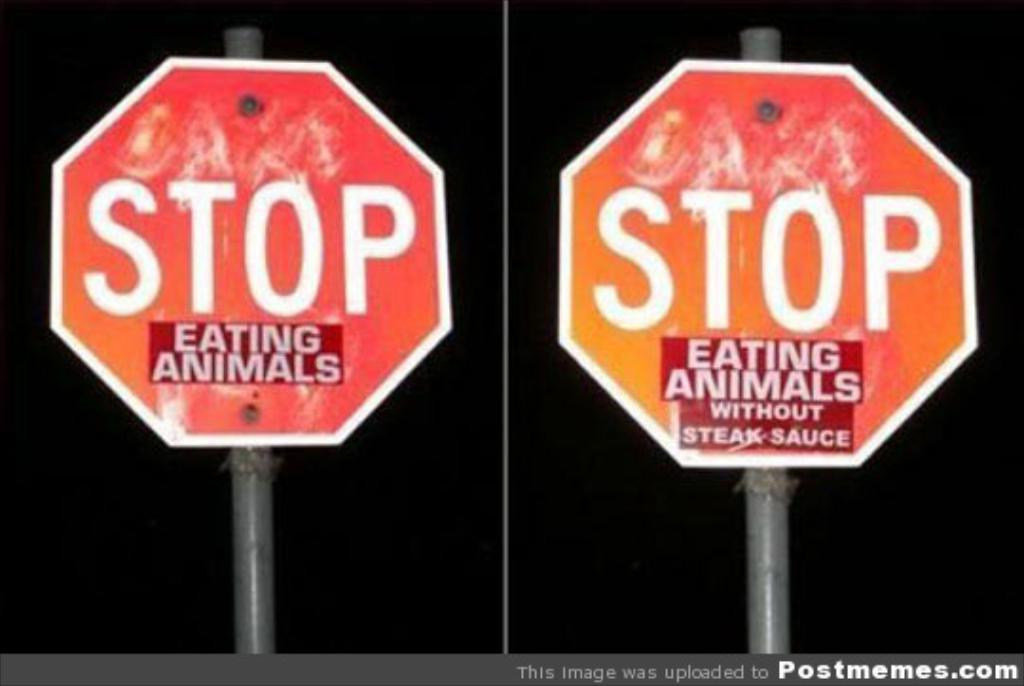<image>
Create a compact narrative representing the image presented. A red stop sign with a sticker on it that says eating animals. 